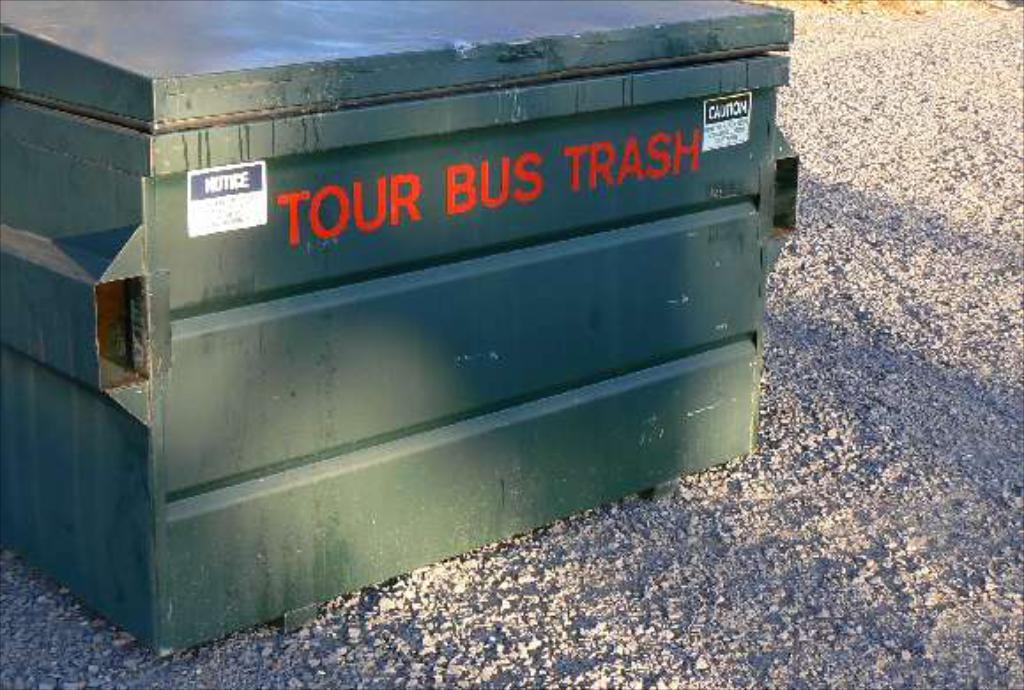<image>
Offer a succinct explanation of the picture presented. A metal box labelled Tour Bus Trash is outside in some gravel. 